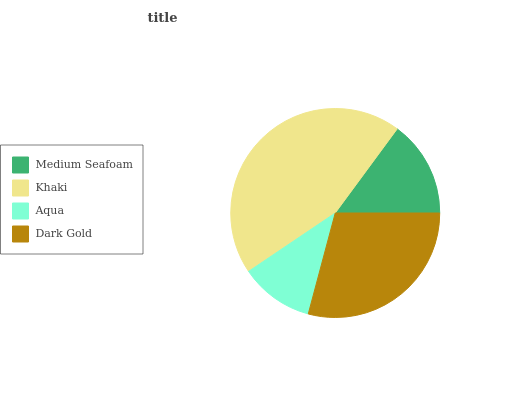Is Aqua the minimum?
Answer yes or no. Yes. Is Khaki the maximum?
Answer yes or no. Yes. Is Khaki the minimum?
Answer yes or no. No. Is Aqua the maximum?
Answer yes or no. No. Is Khaki greater than Aqua?
Answer yes or no. Yes. Is Aqua less than Khaki?
Answer yes or no. Yes. Is Aqua greater than Khaki?
Answer yes or no. No. Is Khaki less than Aqua?
Answer yes or no. No. Is Dark Gold the high median?
Answer yes or no. Yes. Is Medium Seafoam the low median?
Answer yes or no. Yes. Is Khaki the high median?
Answer yes or no. No. Is Khaki the low median?
Answer yes or no. No. 